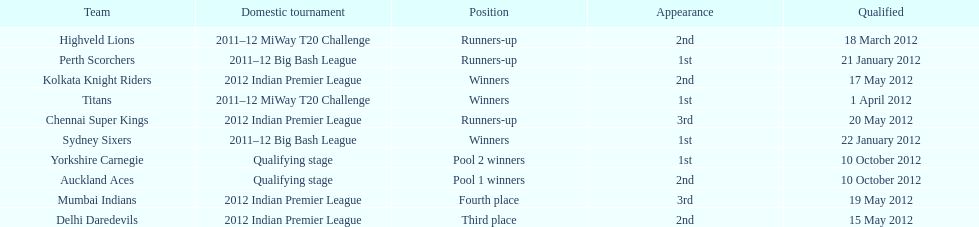Which game came in first in the 2012 indian premier league? Kolkata Knight Riders. Could you parse the entire table? {'header': ['Team', 'Domestic tournament', 'Position', 'Appearance', 'Qualified'], 'rows': [['Highveld Lions', '2011–12 MiWay T20 Challenge', 'Runners-up', '2nd', '18 March 2012'], ['Perth Scorchers', '2011–12 Big Bash League', 'Runners-up', '1st', '21 January 2012'], ['Kolkata Knight Riders', '2012 Indian Premier League', 'Winners', '2nd', '17 May 2012'], ['Titans', '2011–12 MiWay T20 Challenge', 'Winners', '1st', '1 April 2012'], ['Chennai Super Kings', '2012 Indian Premier League', 'Runners-up', '3rd', '20 May 2012'], ['Sydney Sixers', '2011–12 Big Bash League', 'Winners', '1st', '22 January 2012'], ['Yorkshire Carnegie', 'Qualifying stage', 'Pool 2 winners', '1st', '10 October 2012'], ['Auckland Aces', 'Qualifying stage', 'Pool 1 winners', '2nd', '10 October 2012'], ['Mumbai Indians', '2012 Indian Premier League', 'Fourth place', '3rd', '19 May 2012'], ['Delhi Daredevils', '2012 Indian Premier League', 'Third place', '2nd', '15 May 2012']]} 